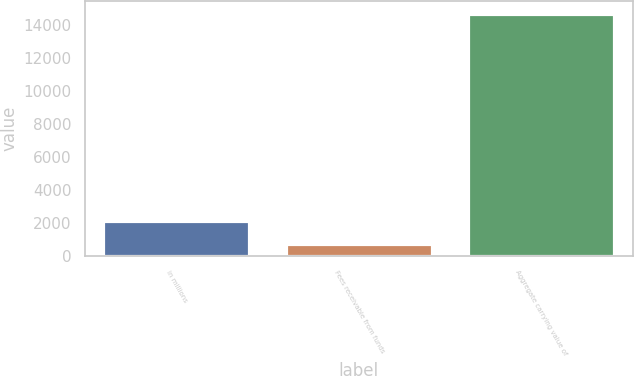<chart> <loc_0><loc_0><loc_500><loc_500><bar_chart><fcel>in millions<fcel>Fees receivable from funds<fcel>Aggregate carrying value of<nl><fcel>2106.1<fcel>704<fcel>14725<nl></chart> 